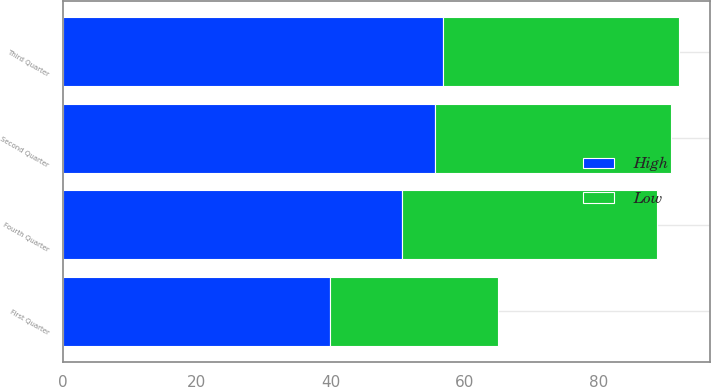<chart> <loc_0><loc_0><loc_500><loc_500><stacked_bar_chart><ecel><fcel>First Quarter<fcel>Second Quarter<fcel>Third Quarter<fcel>Fourth Quarter<nl><fcel>High<fcel>39.9<fcel>55.61<fcel>56.71<fcel>50.7<nl><fcel>Low<fcel>25.08<fcel>35.26<fcel>35.36<fcel>38.07<nl></chart> 